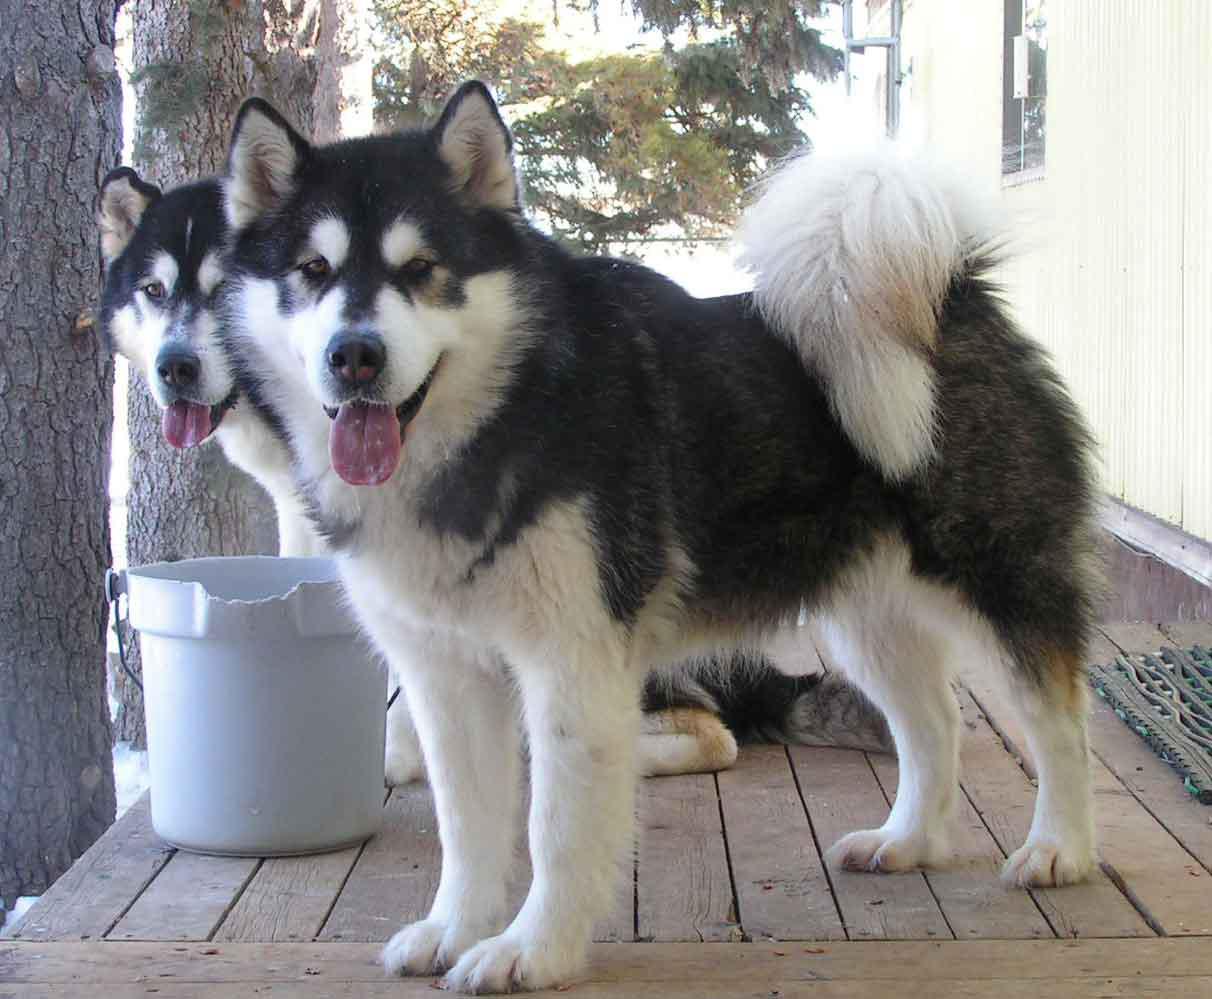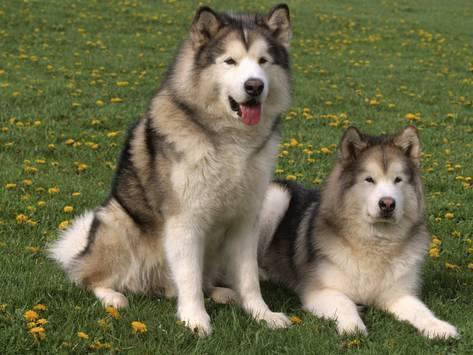The first image is the image on the left, the second image is the image on the right. Examine the images to the left and right. Is the description "One image shows a dog standing still in profile facing leftward, with its tail upcurled, and the other image shows a dog with its body turned leftward but its head turned forward and its tail hanging down." accurate? Answer yes or no. No. The first image is the image on the left, the second image is the image on the right. Assess this claim about the two images: "Every photo shows exactly one dog, facing left, photographed outside, and not being accompanied by a human.". Correct or not? Answer yes or no. No. 